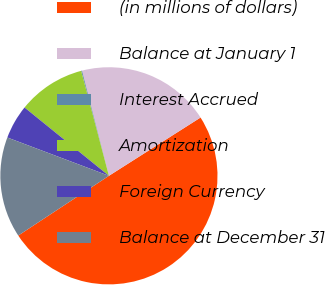Convert chart. <chart><loc_0><loc_0><loc_500><loc_500><pie_chart><fcel>(in millions of dollars)<fcel>Balance at January 1<fcel>Interest Accrued<fcel>Amortization<fcel>Foreign Currency<fcel>Balance at December 31<nl><fcel>49.74%<fcel>19.97%<fcel>0.13%<fcel>10.05%<fcel>5.09%<fcel>15.01%<nl></chart> 